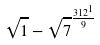Convert formula to latex. <formula><loc_0><loc_0><loc_500><loc_500>\sqrt { 1 } - \sqrt { 7 } ^ { \frac { 3 1 2 ^ { 1 } } { 9 } }</formula> 